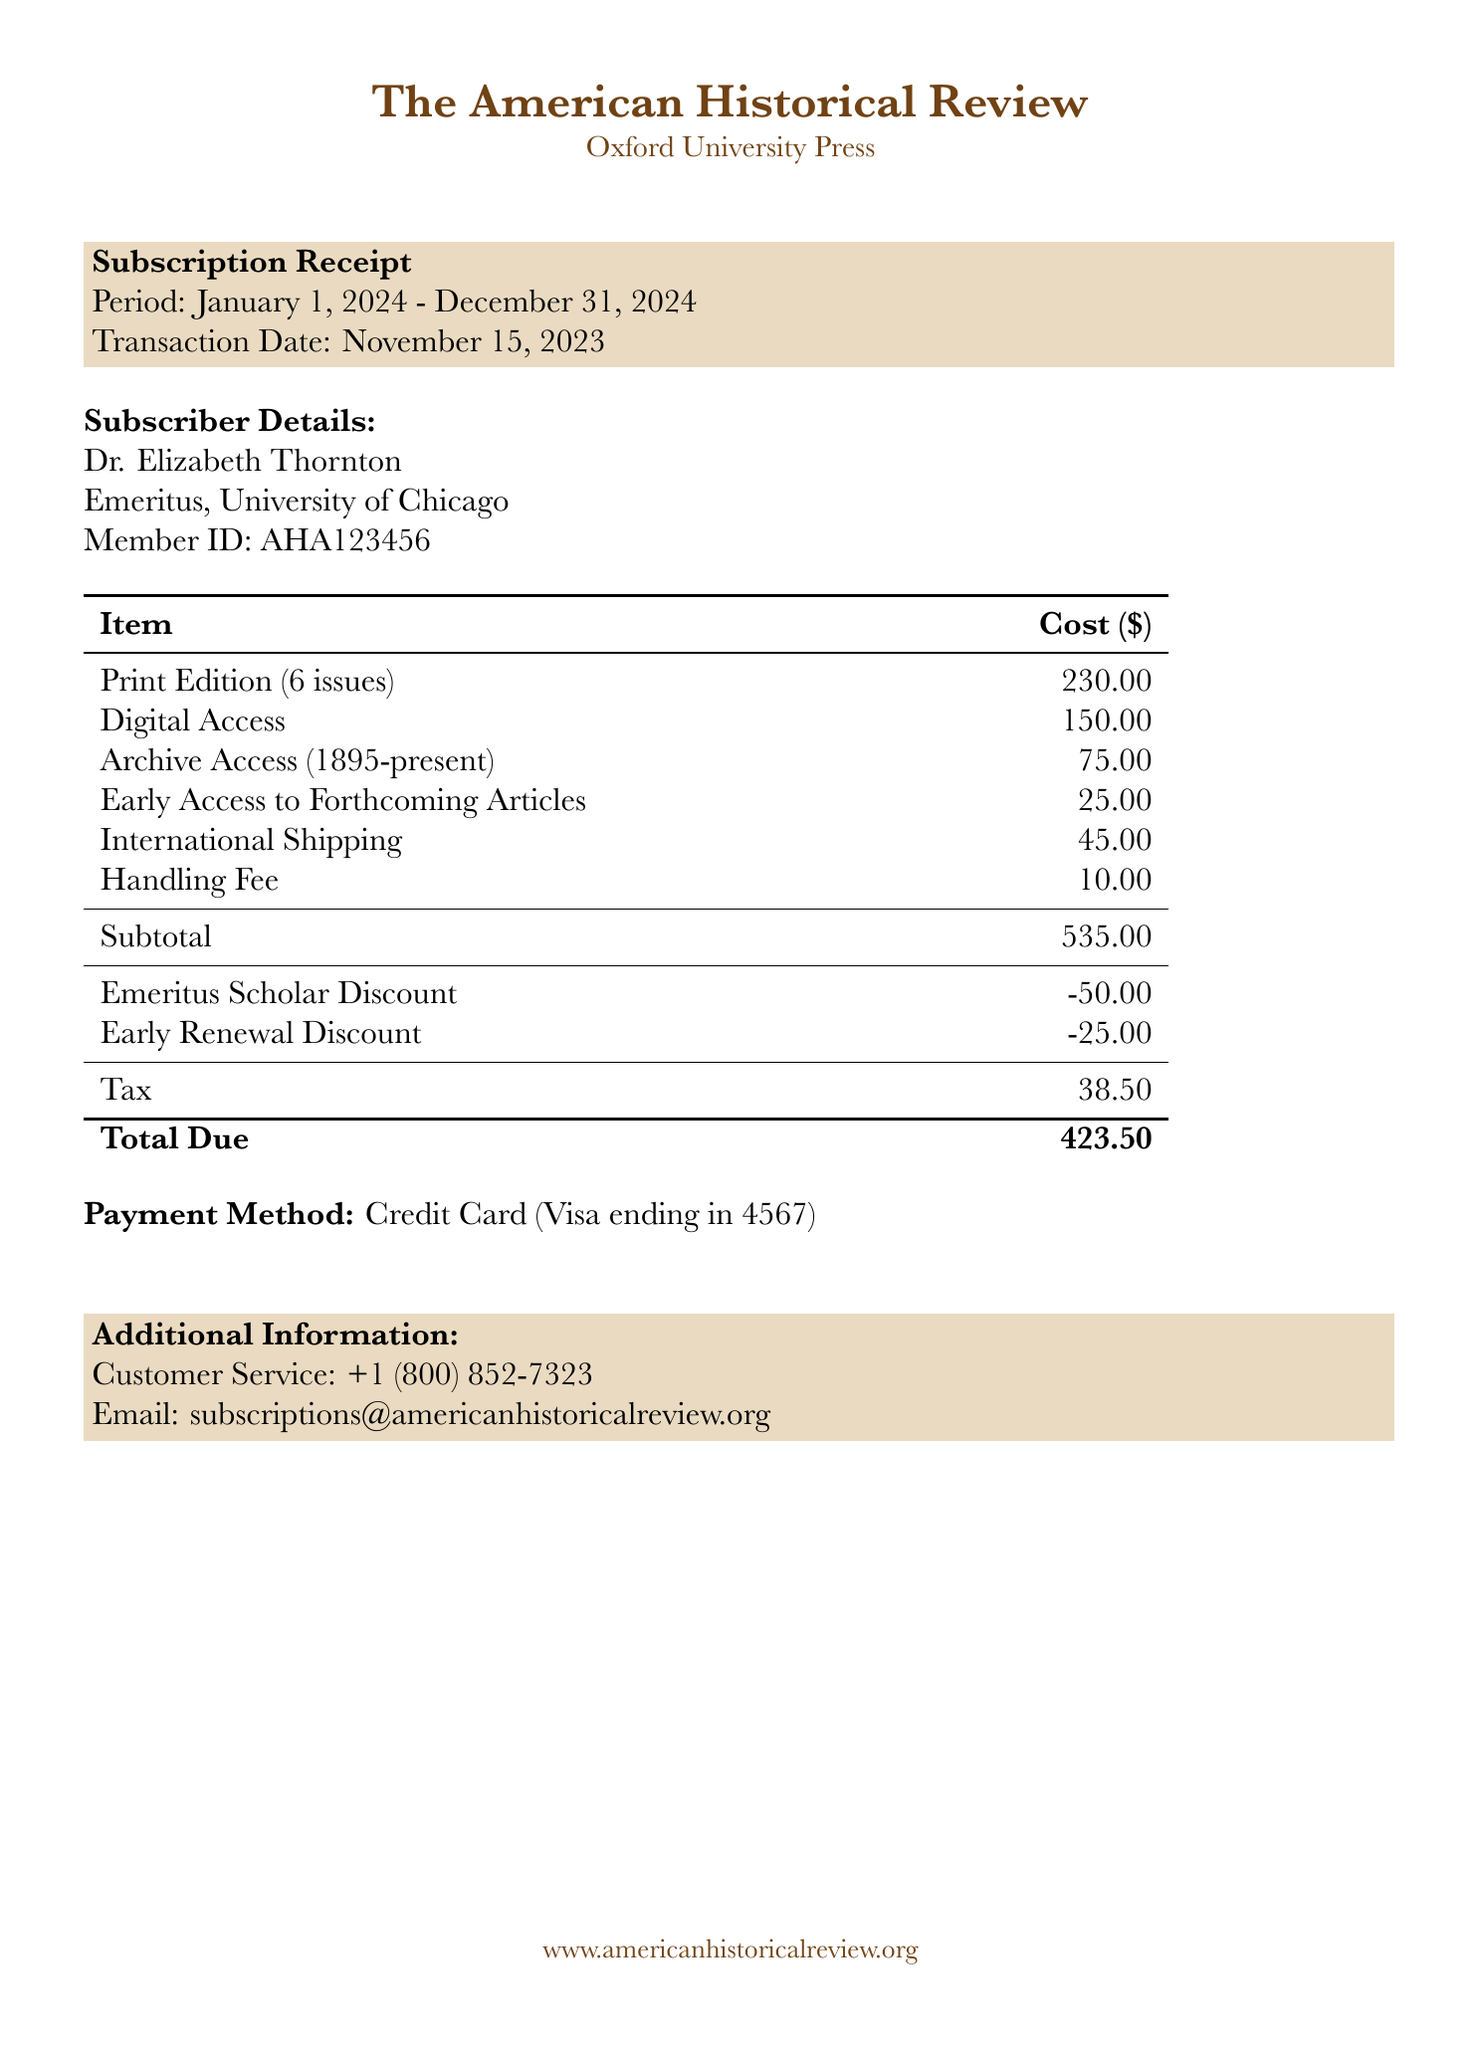What is the journal name? The journal name is prominently displayed at the top of the document.
Answer: The American Historical Review Who is the publisher? The publisher name is mentioned alongside the journal name.
Answer: Oxford University Press What is the subscription period? The subscription period is specified within the subscription details.
Answer: January 1, 2024 - December 31, 2024 What is the total due amount? The total due is clearly indicated at the bottom of the cost breakdown table.
Answer: 423.50 How many issues are included in the Print Edition? The number of issues is stated next to the item description for the Print Edition.
Answer: 6 issues What discount is applied for Emeritus Scholars? The discount for Emeritus Scholars is found in the discounts section of the document.
Answer: -50.00 What is the cost of Digital Access? The cost of Digital Access is listed in the subscription items section.
Answer: 150.00 What date was the transaction made? The transaction date is displayed within the subscription receipt details.
Answer: November 15, 2023 What is the handling fee? The handling fee is specified in the additional charges section of the document.
Answer: 10.00 